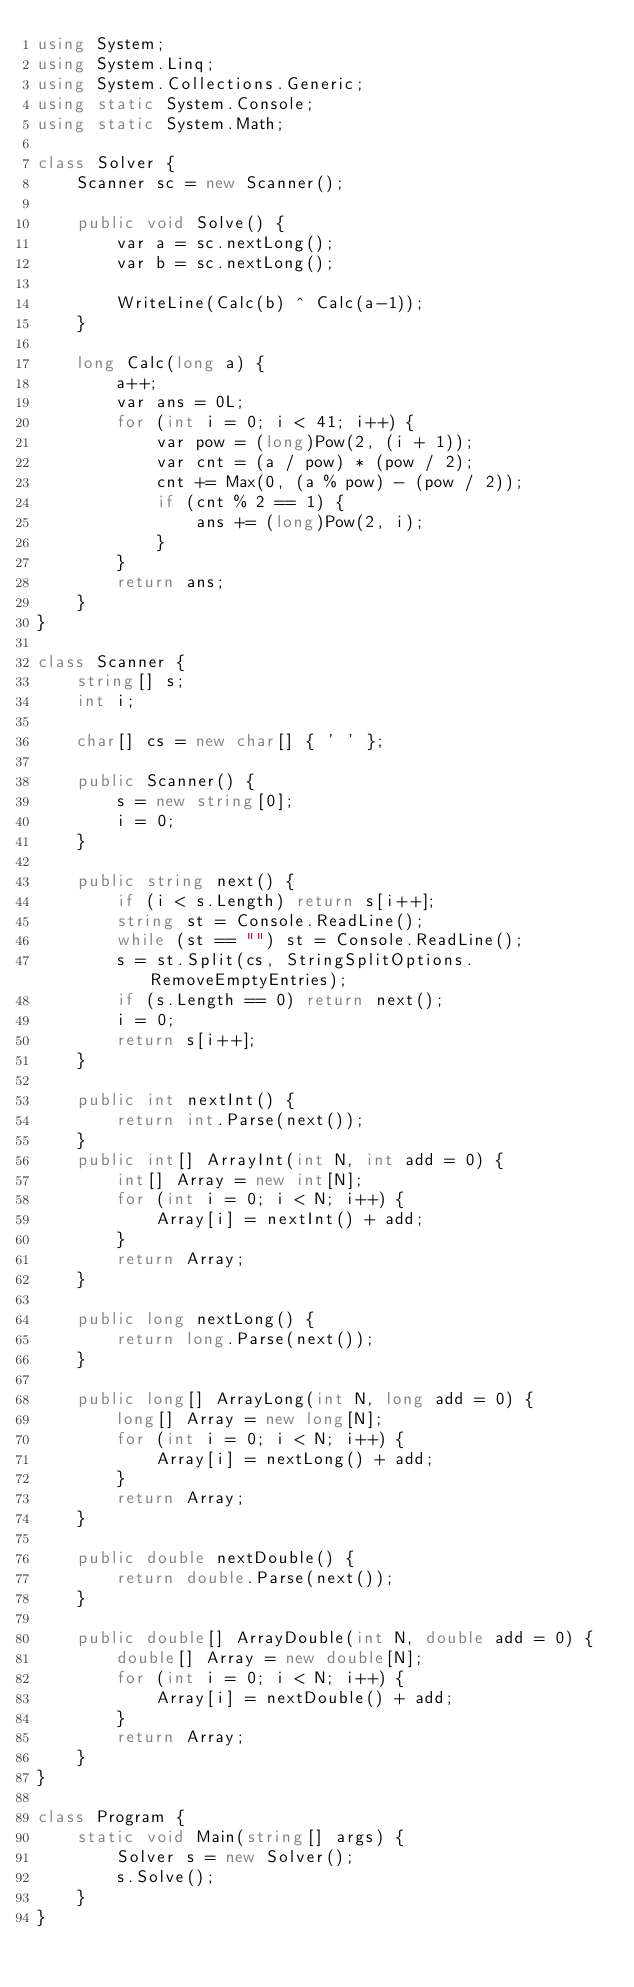Convert code to text. <code><loc_0><loc_0><loc_500><loc_500><_C#_>using System;
using System.Linq;
using System.Collections.Generic;
using static System.Console;
using static System.Math;

class Solver {
    Scanner sc = new Scanner();

    public void Solve() {
        var a = sc.nextLong();
        var b = sc.nextLong();

        WriteLine(Calc(b) ^ Calc(a-1));
    }

    long Calc(long a) {
        a++;
        var ans = 0L;
        for (int i = 0; i < 41; i++) {
            var pow = (long)Pow(2, (i + 1));
            var cnt = (a / pow) * (pow / 2);
            cnt += Max(0, (a % pow) - (pow / 2));
            if (cnt % 2 == 1) {
                ans += (long)Pow(2, i);
            }
        }
        return ans;
    }
}

class Scanner {
    string[] s;
    int i;

    char[] cs = new char[] { ' ' };

    public Scanner() {
        s = new string[0];
        i = 0;
    }

    public string next() {
        if (i < s.Length) return s[i++];
        string st = Console.ReadLine();
        while (st == "") st = Console.ReadLine();
        s = st.Split(cs, StringSplitOptions.RemoveEmptyEntries);
        if (s.Length == 0) return next();
        i = 0;
        return s[i++];
    }

    public int nextInt() {
        return int.Parse(next());
    }
    public int[] ArrayInt(int N, int add = 0) {
        int[] Array = new int[N];
        for (int i = 0; i < N; i++) {
            Array[i] = nextInt() + add;
        }
        return Array;
    }

    public long nextLong() {
        return long.Parse(next());
    }

    public long[] ArrayLong(int N, long add = 0) {
        long[] Array = new long[N];
        for (int i = 0; i < N; i++) {
            Array[i] = nextLong() + add;
        }
        return Array;
    }

    public double nextDouble() {
        return double.Parse(next());
    }

    public double[] ArrayDouble(int N, double add = 0) {
        double[] Array = new double[N];
        for (int i = 0; i < N; i++) {
            Array[i] = nextDouble() + add;
        }
        return Array;
    }
}

class Program {
    static void Main(string[] args) {
        Solver s = new Solver();
        s.Solve();
    }
}
</code> 